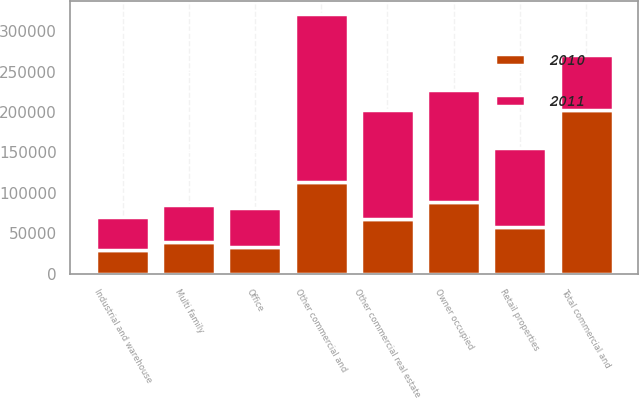Convert chart to OTSL. <chart><loc_0><loc_0><loc_500><loc_500><stacked_bar_chart><ecel><fcel>Owner occupied<fcel>Other commercial and<fcel>Total commercial and<fcel>Retail properties<fcel>Multi family<fcel>Office<fcel>Industrial and warehouse<fcel>Other commercial real estate<nl><fcel>2010<fcel>88415<fcel>113431<fcel>201846<fcel>58415<fcel>39921<fcel>33202<fcel>30119<fcel>68232<nl><fcel>2011<fcel>138822<fcel>207898<fcel>68232<fcel>96644<fcel>44819<fcel>47950<fcel>39770<fcel>134509<nl></chart> 